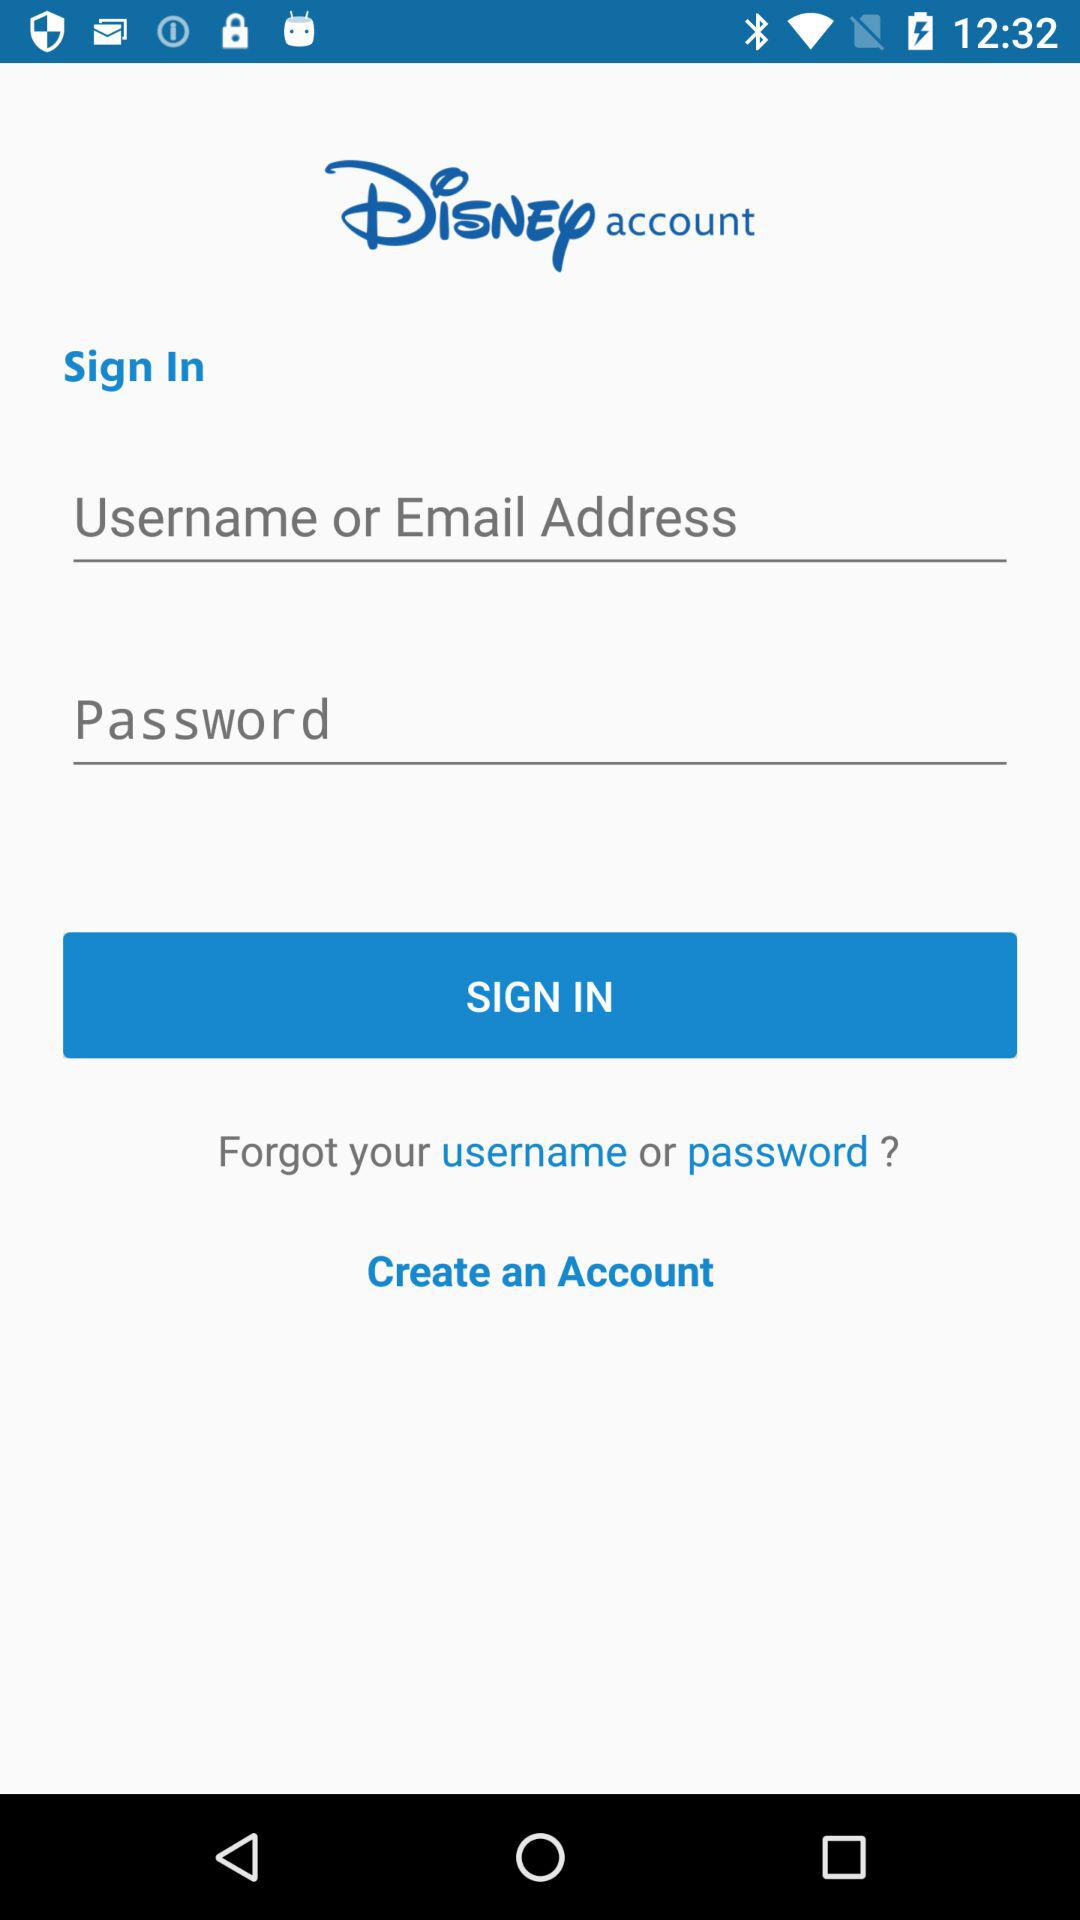Can we reset username?
When the provided information is insufficient, respond with <no answer>. <no answer> 